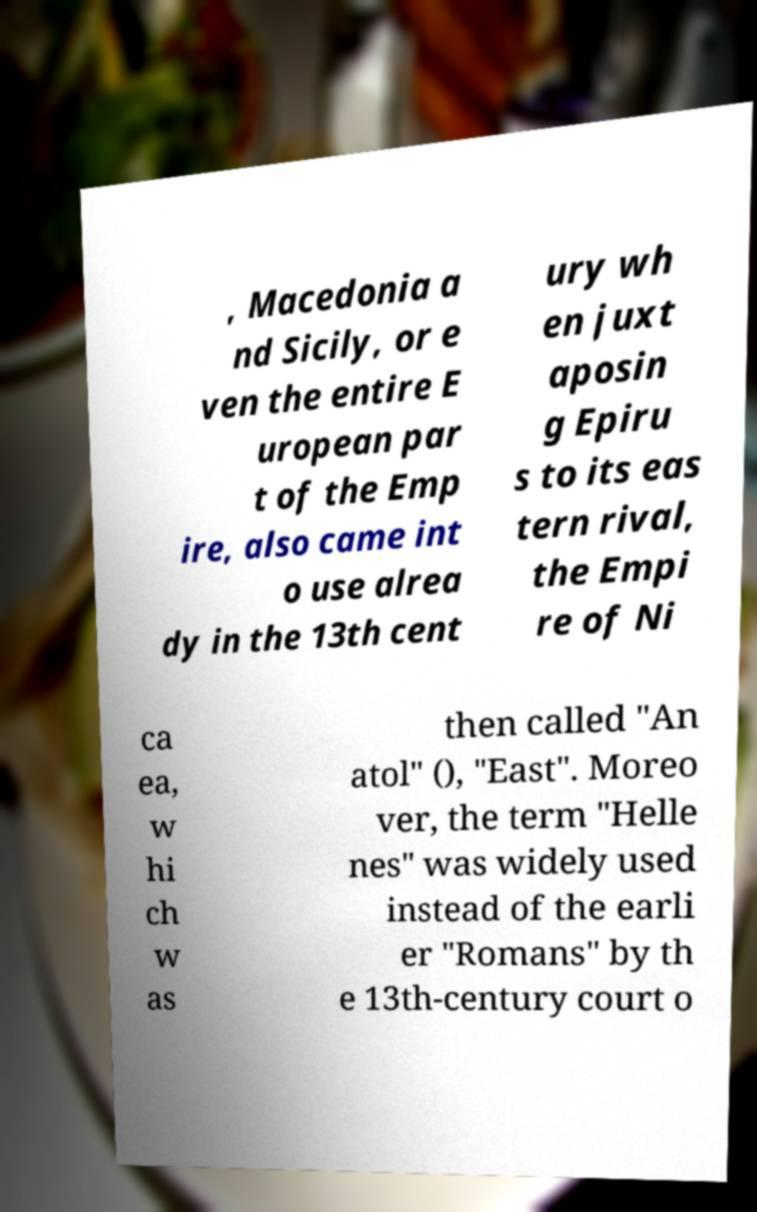Please identify and transcribe the text found in this image. , Macedonia a nd Sicily, or e ven the entire E uropean par t of the Emp ire, also came int o use alrea dy in the 13th cent ury wh en juxt aposin g Epiru s to its eas tern rival, the Empi re of Ni ca ea, w hi ch w as then called "An atol" (), "East". Moreo ver, the term "Helle nes" was widely used instead of the earli er "Romans" by th e 13th-century court o 